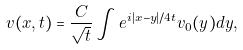<formula> <loc_0><loc_0><loc_500><loc_500>v ( x , t ) = \frac { C } { \sqrt { t } } \int e ^ { i | x - y | / 4 t } v _ { 0 } ( y ) d y ,</formula> 